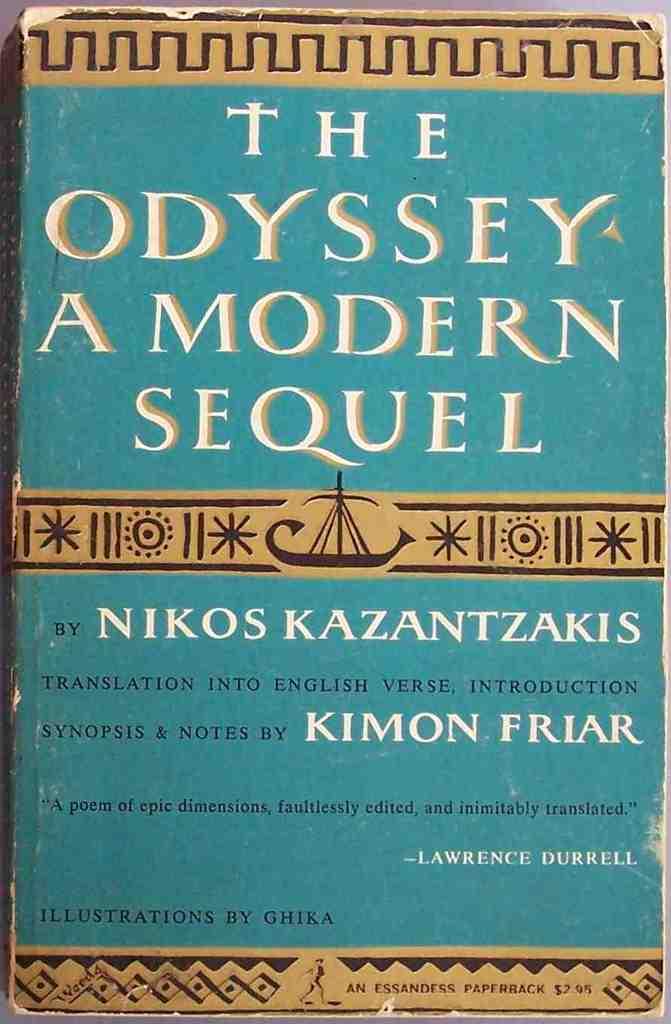What is the title of the book?
Your response must be concise. The odyssey a modern sequel. Who illustrated this book?
Offer a very short reply. Ghika. 